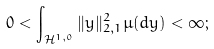Convert formula to latex. <formula><loc_0><loc_0><loc_500><loc_500>0 < \int _ { \mathcal { H } ^ { 1 , 0 } } \| y \| _ { 2 , 1 } ^ { 2 } \mu ( d y ) < \infty ;</formula> 